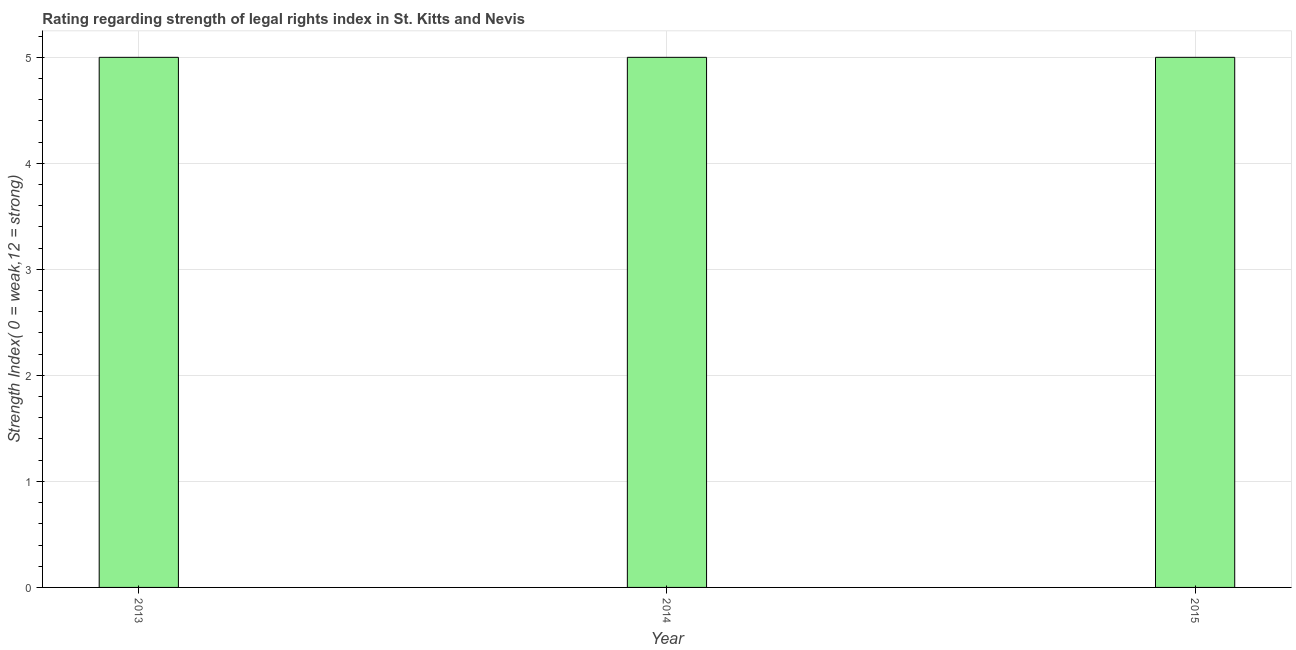Does the graph contain any zero values?
Give a very brief answer. No. Does the graph contain grids?
Make the answer very short. Yes. What is the title of the graph?
Make the answer very short. Rating regarding strength of legal rights index in St. Kitts and Nevis. What is the label or title of the Y-axis?
Ensure brevity in your answer.  Strength Index( 0 = weak,12 = strong). What is the strength of legal rights index in 2015?
Your response must be concise. 5. Across all years, what is the maximum strength of legal rights index?
Keep it short and to the point. 5. Across all years, what is the minimum strength of legal rights index?
Your answer should be very brief. 5. What is the difference between the strength of legal rights index in 2013 and 2015?
Your response must be concise. 0. What is the ratio of the strength of legal rights index in 2013 to that in 2014?
Give a very brief answer. 1. Is the strength of legal rights index in 2014 less than that in 2015?
Your answer should be compact. No. Is the difference between the strength of legal rights index in 2014 and 2015 greater than the difference between any two years?
Offer a terse response. Yes. What is the difference between the highest and the lowest strength of legal rights index?
Offer a terse response. 0. In how many years, is the strength of legal rights index greater than the average strength of legal rights index taken over all years?
Keep it short and to the point. 0. Are all the bars in the graph horizontal?
Ensure brevity in your answer.  No. Are the values on the major ticks of Y-axis written in scientific E-notation?
Your answer should be compact. No. What is the Strength Index( 0 = weak,12 = strong) of 2014?
Your answer should be compact. 5. What is the Strength Index( 0 = weak,12 = strong) in 2015?
Your answer should be compact. 5. What is the ratio of the Strength Index( 0 = weak,12 = strong) in 2013 to that in 2014?
Ensure brevity in your answer.  1. 